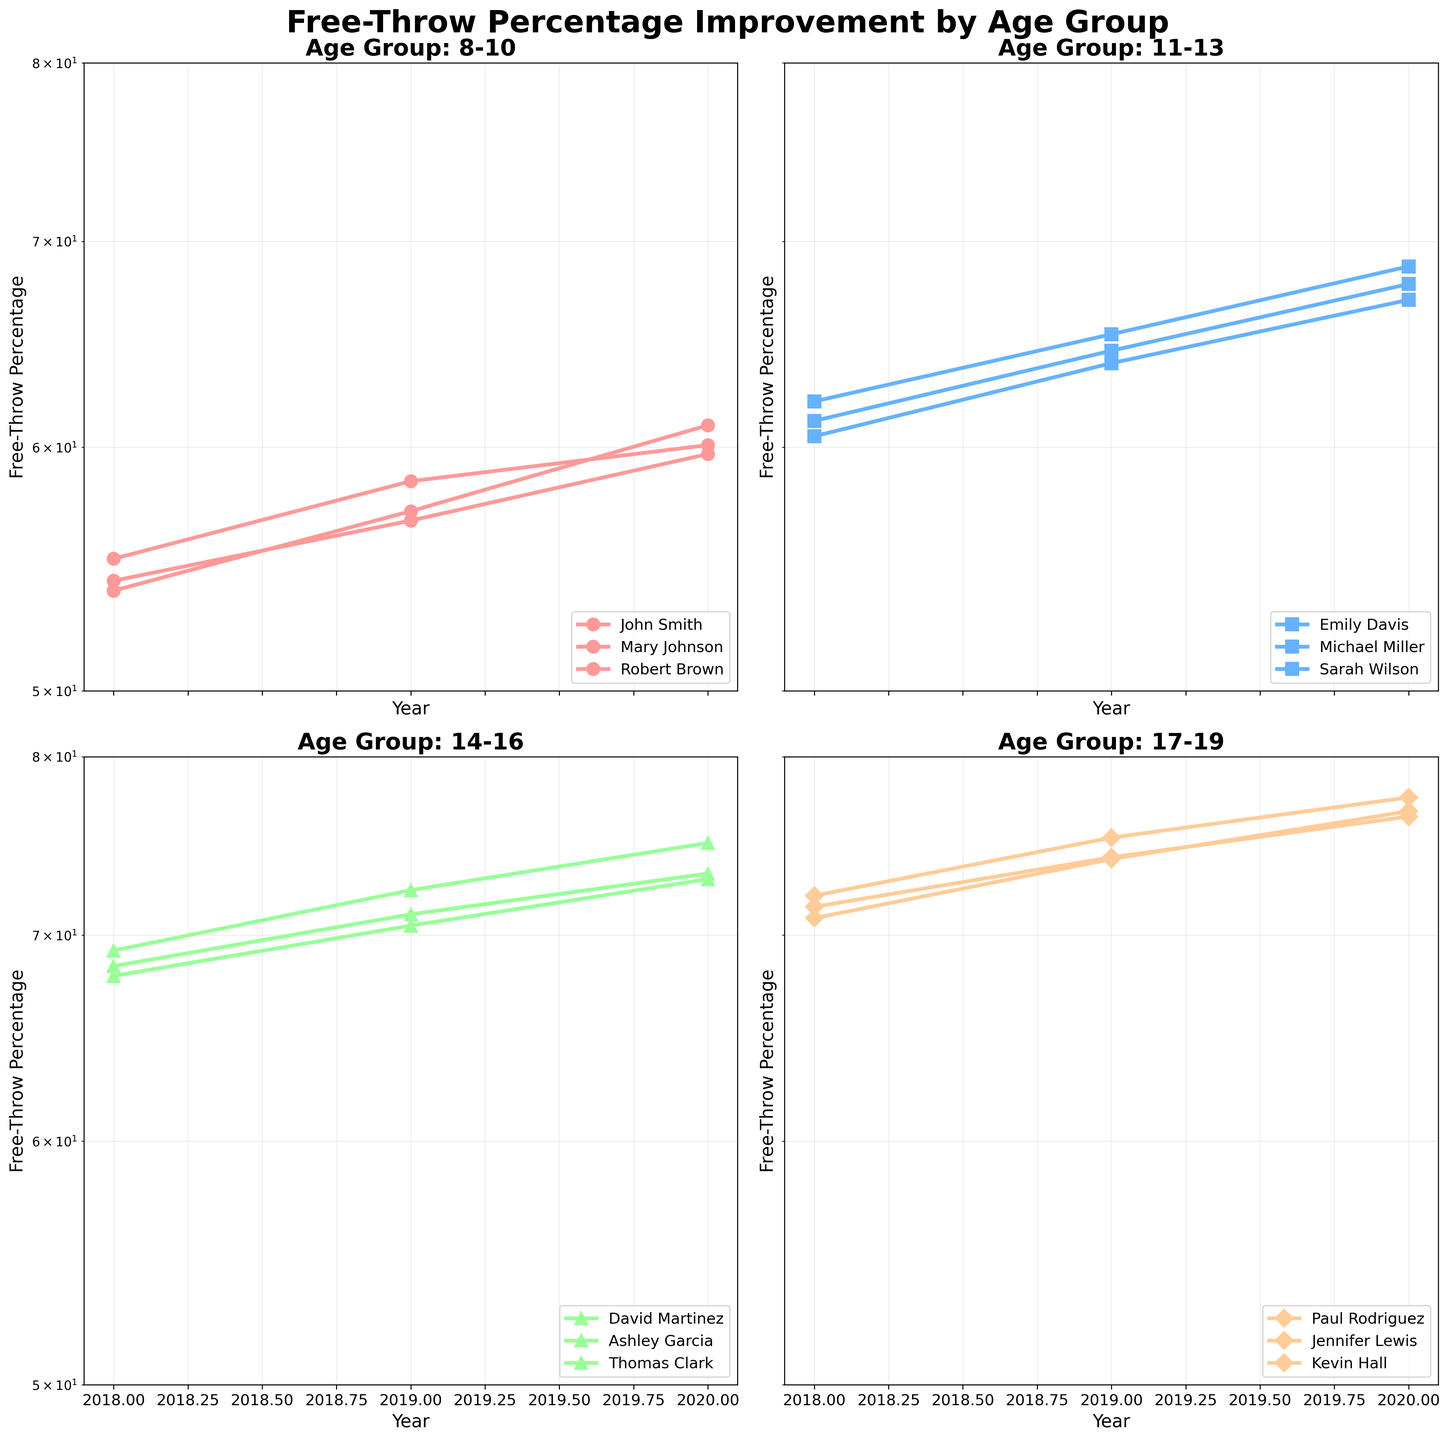Which age group shows the largest overall improvement in free-throw percentage over the years? To determine the improvement, check the difference in free-throw percentage between 2018 and 2020 for each age group. The Age Group 17-19, especially Paul Rodriguez, seems to have a significant overall improvement, as they move from lower percentages to higher in a compact range.
Answer: 17-19 What is the title of the subplot in the top-left corner? Locate the subplot in the top-left corner, and the title displayed there describes the data for Age Group 8-10.
Answer: Age Group: 8-10 Which player in the 14-16 age group demonstrated the highest percentage in 2020? Navigate to the subplot corresponding to the age group 14-16. Compare the data points for 2020. Ashley Garcia has the highest value at 75.0.
Answer: Ashley Garcia How does the year influence the free-throw percentages in the 11-13 age group? Observe the trend lines in the subplot for the 11-13 age group. All players show a positive trend in their free-throw percentage from 2018 to 2020, indicating an increase each year.
Answer: Increases each year Who had the highest free-throw percentage across all age groups in 2020? Look for the highest data point among all subplots for the year 2020. Ashley Garcia from Age Group 14-16 shows the top percentage at 75.0.
Answer: Ashley Garcia Which player shows the smallest increase in free-throw percentage between 2018 and 2020 in the 11-13 age group? In the subplot of the 11-13 age group, calculate the differences for each player between 2018 and 2020. Sarah Wilson has the smallest increase (67.0 - 60.5 = 6.5).
Answer: Sarah Wilson Compare the free-throw percentages of John Smith and Kevin Hall in 2019. Who had a higher percentage? Look at the subplots for Age Groups 8-10 and 17-19. Compare John Smith in 8-10 and Kevin Hall in 17-19 for the year 2019. Kevin Hall's percentage of 74.1 is higher than John Smith's 58.5.
Answer: Kevin Hall Which player in the 8-10 age group had the most significant improvement from 2018 to 2020? In the subplot for the 8-10 age group, calculate the differences. Robert Brown improved the most, from 53.9 to 61.0, a difference of 7.1.
Answer: Robert Brown Does the 17-19 age group have any players with a worse free-throw percentage in 2019 compared to 2018? Examine the data points for each player in the 17-19 age group between 2018 and 2019. All players improved, showing no decrease in percentages.
Answer: No 